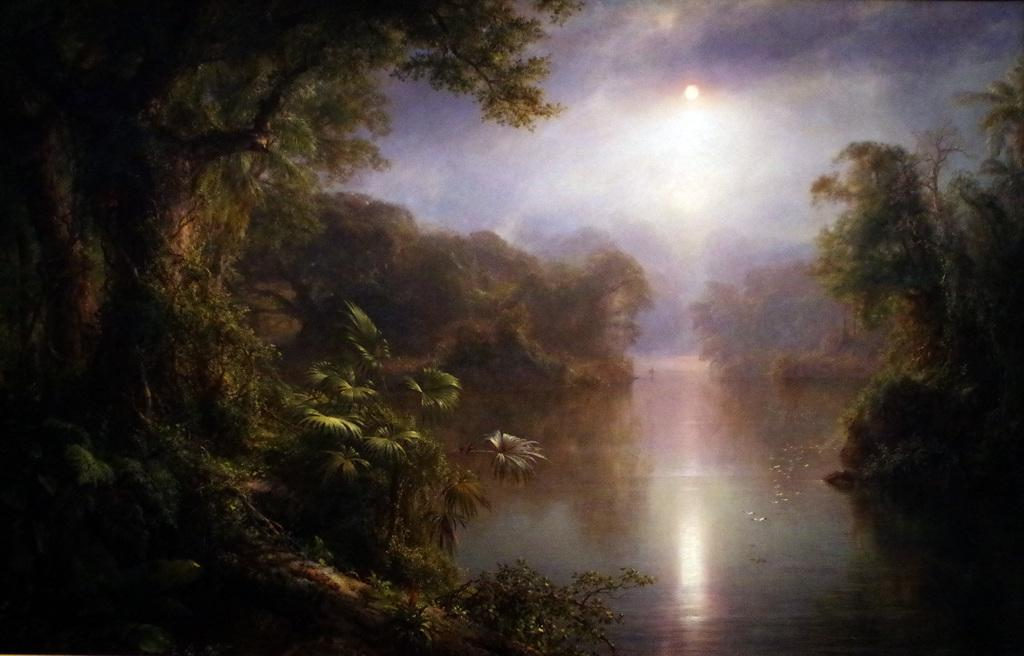What type of vegetation can be seen in the image? There are trees and plants in the image. What natural element is visible in the image? Water is visible in the image. What is visible in the sky in the image? The sky is visible in the image, and there are clouds and the sun present. Can you see a girl wearing a scarf in the image? There is no girl wearing a scarf present in the image. What type of animal can be seen grazing in the image? There are no animals visible in the image, only trees, plants, water, and the sky. 